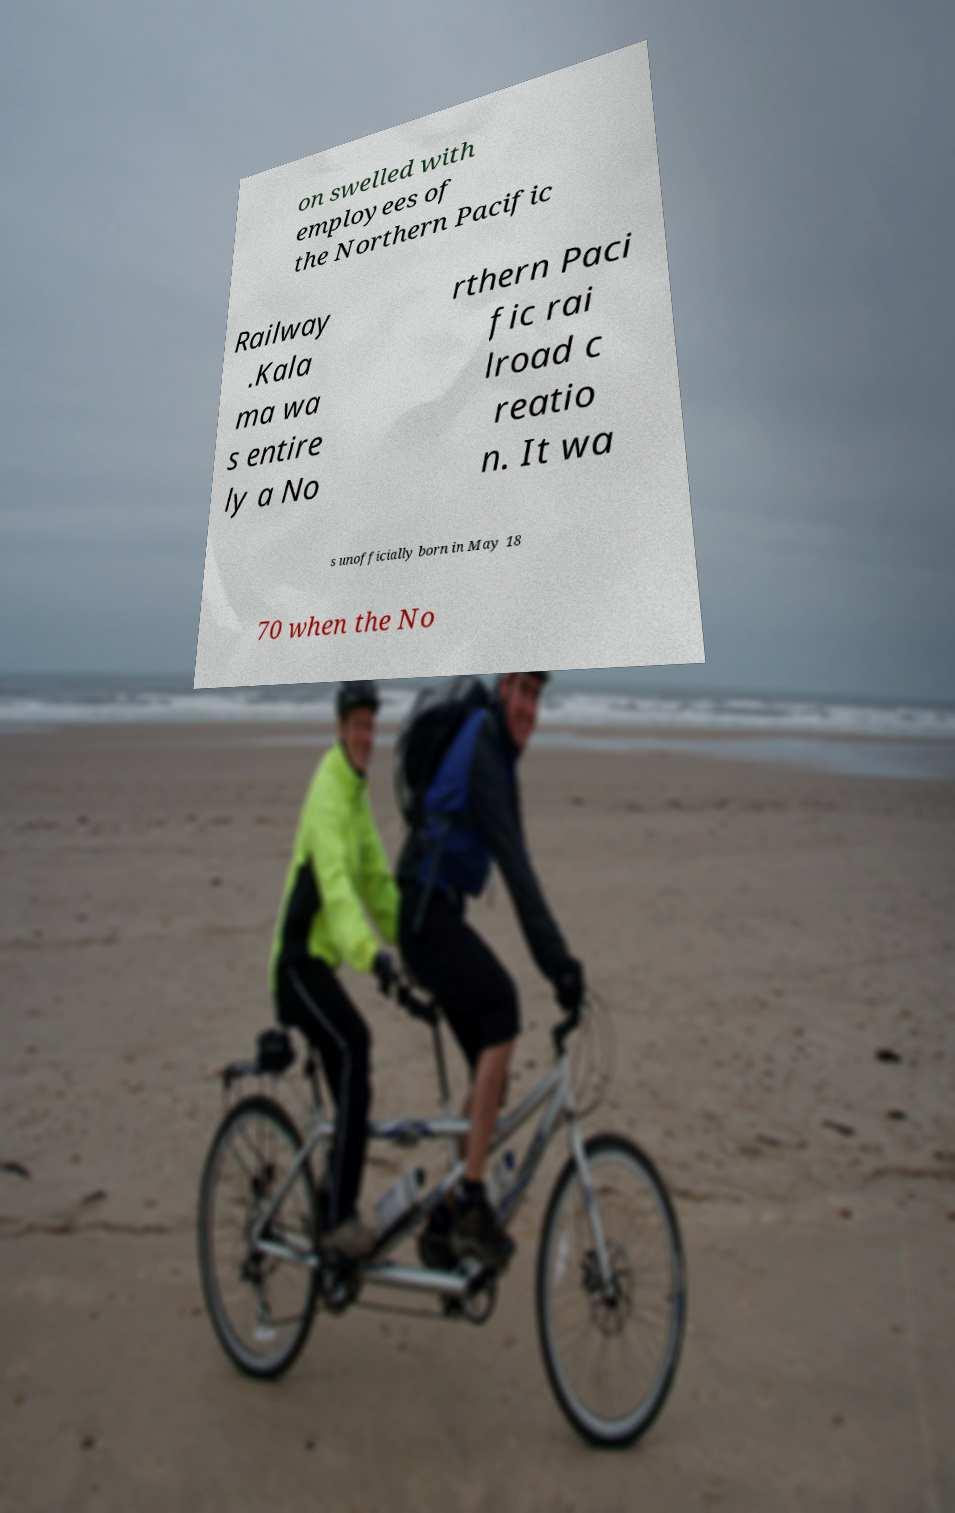Can you read and provide the text displayed in the image?This photo seems to have some interesting text. Can you extract and type it out for me? on swelled with employees of the Northern Pacific Railway .Kala ma wa s entire ly a No rthern Paci fic rai lroad c reatio n. It wa s unofficially born in May 18 70 when the No 